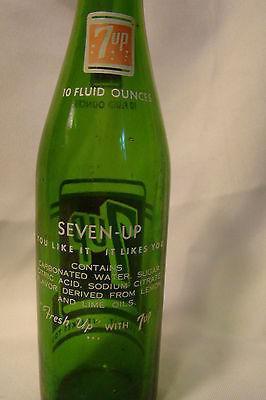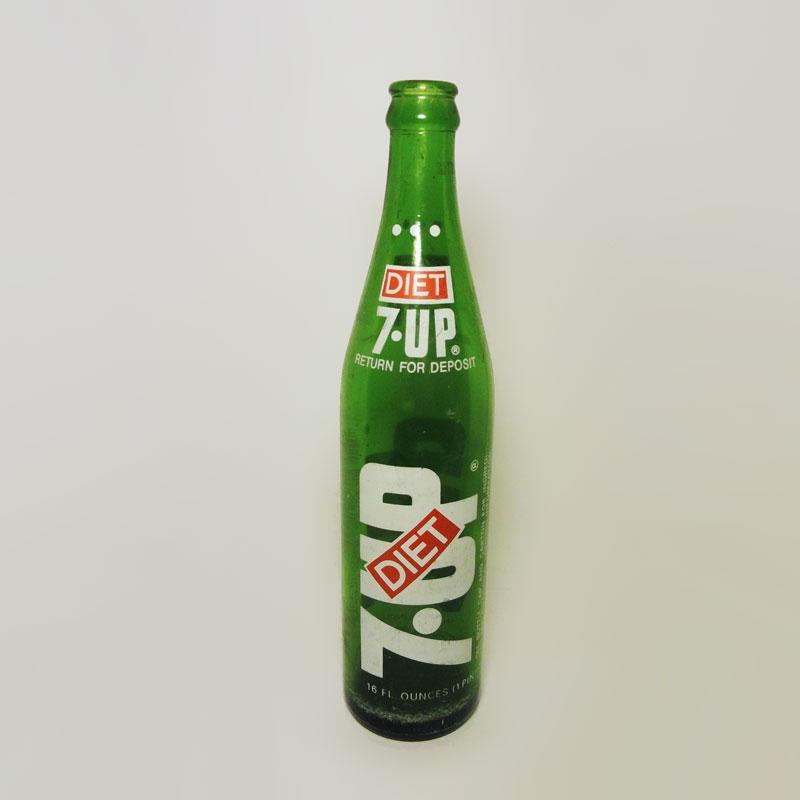The first image is the image on the left, the second image is the image on the right. Evaluate the accuracy of this statement regarding the images: "There are two bottles, one glass and one plastic.". Is it true? Answer yes or no. No. 